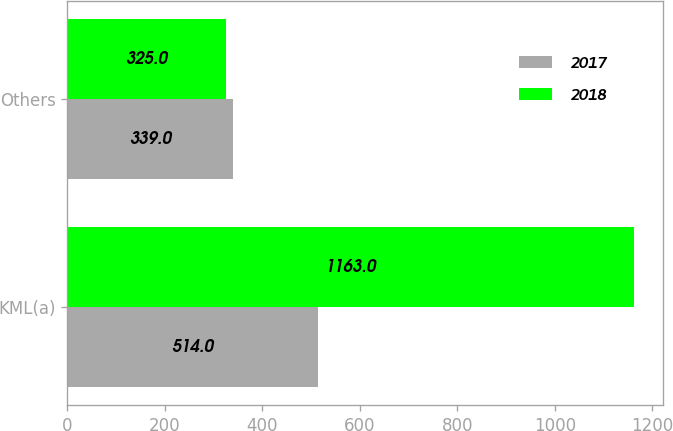Convert chart. <chart><loc_0><loc_0><loc_500><loc_500><stacked_bar_chart><ecel><fcel>KML(a)<fcel>Others<nl><fcel>2017<fcel>514<fcel>339<nl><fcel>2018<fcel>1163<fcel>325<nl></chart> 